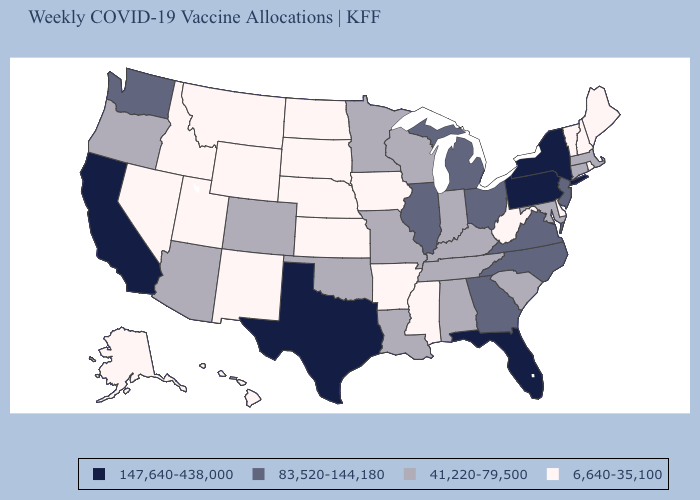Does Utah have the lowest value in the USA?
Answer briefly. Yes. Among the states that border Nebraska , does Colorado have the lowest value?
Concise answer only. No. What is the value of Tennessee?
Give a very brief answer. 41,220-79,500. Name the states that have a value in the range 6,640-35,100?
Keep it brief. Alaska, Arkansas, Delaware, Hawaii, Idaho, Iowa, Kansas, Maine, Mississippi, Montana, Nebraska, Nevada, New Hampshire, New Mexico, North Dakota, Rhode Island, South Dakota, Utah, Vermont, West Virginia, Wyoming. Does the first symbol in the legend represent the smallest category?
Be succinct. No. Name the states that have a value in the range 6,640-35,100?
Write a very short answer. Alaska, Arkansas, Delaware, Hawaii, Idaho, Iowa, Kansas, Maine, Mississippi, Montana, Nebraska, Nevada, New Hampshire, New Mexico, North Dakota, Rhode Island, South Dakota, Utah, Vermont, West Virginia, Wyoming. How many symbols are there in the legend?
Give a very brief answer. 4. What is the highest value in the USA?
Concise answer only. 147,640-438,000. What is the lowest value in the South?
Concise answer only. 6,640-35,100. What is the lowest value in states that border Vermont?
Concise answer only. 6,640-35,100. Name the states that have a value in the range 6,640-35,100?
Short answer required. Alaska, Arkansas, Delaware, Hawaii, Idaho, Iowa, Kansas, Maine, Mississippi, Montana, Nebraska, Nevada, New Hampshire, New Mexico, North Dakota, Rhode Island, South Dakota, Utah, Vermont, West Virginia, Wyoming. Which states have the lowest value in the USA?
Concise answer only. Alaska, Arkansas, Delaware, Hawaii, Idaho, Iowa, Kansas, Maine, Mississippi, Montana, Nebraska, Nevada, New Hampshire, New Mexico, North Dakota, Rhode Island, South Dakota, Utah, Vermont, West Virginia, Wyoming. Does Arizona have a higher value than Michigan?
Answer briefly. No. Does Wisconsin have the lowest value in the MidWest?
Concise answer only. No. 